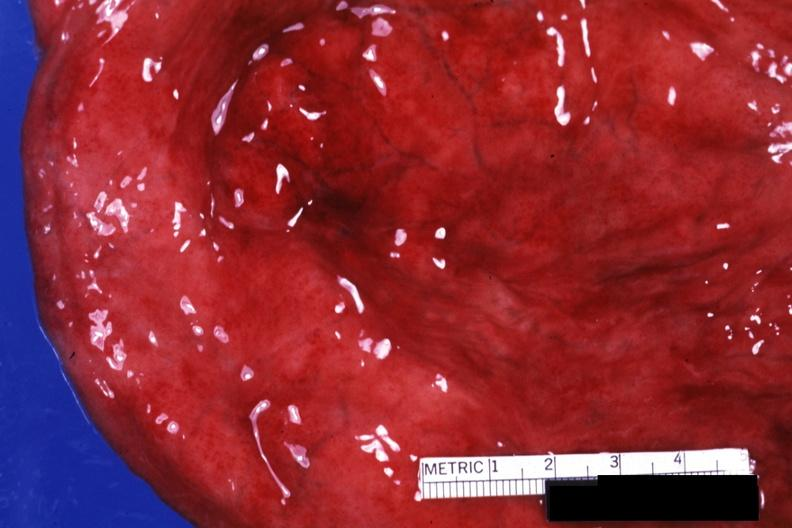what is present?
Answer the question using a single word or phrase. Bladder 